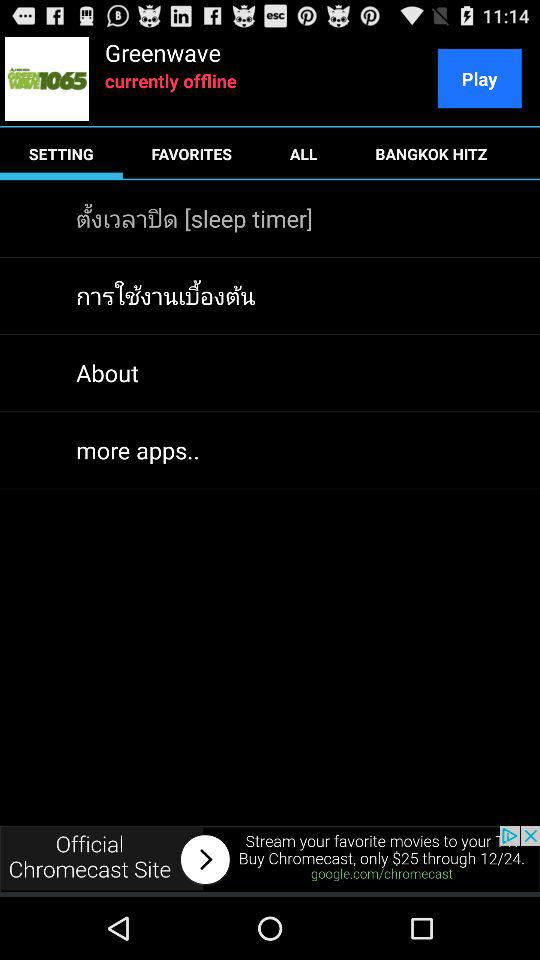What is the status of the user? The status of the user is "offline". 